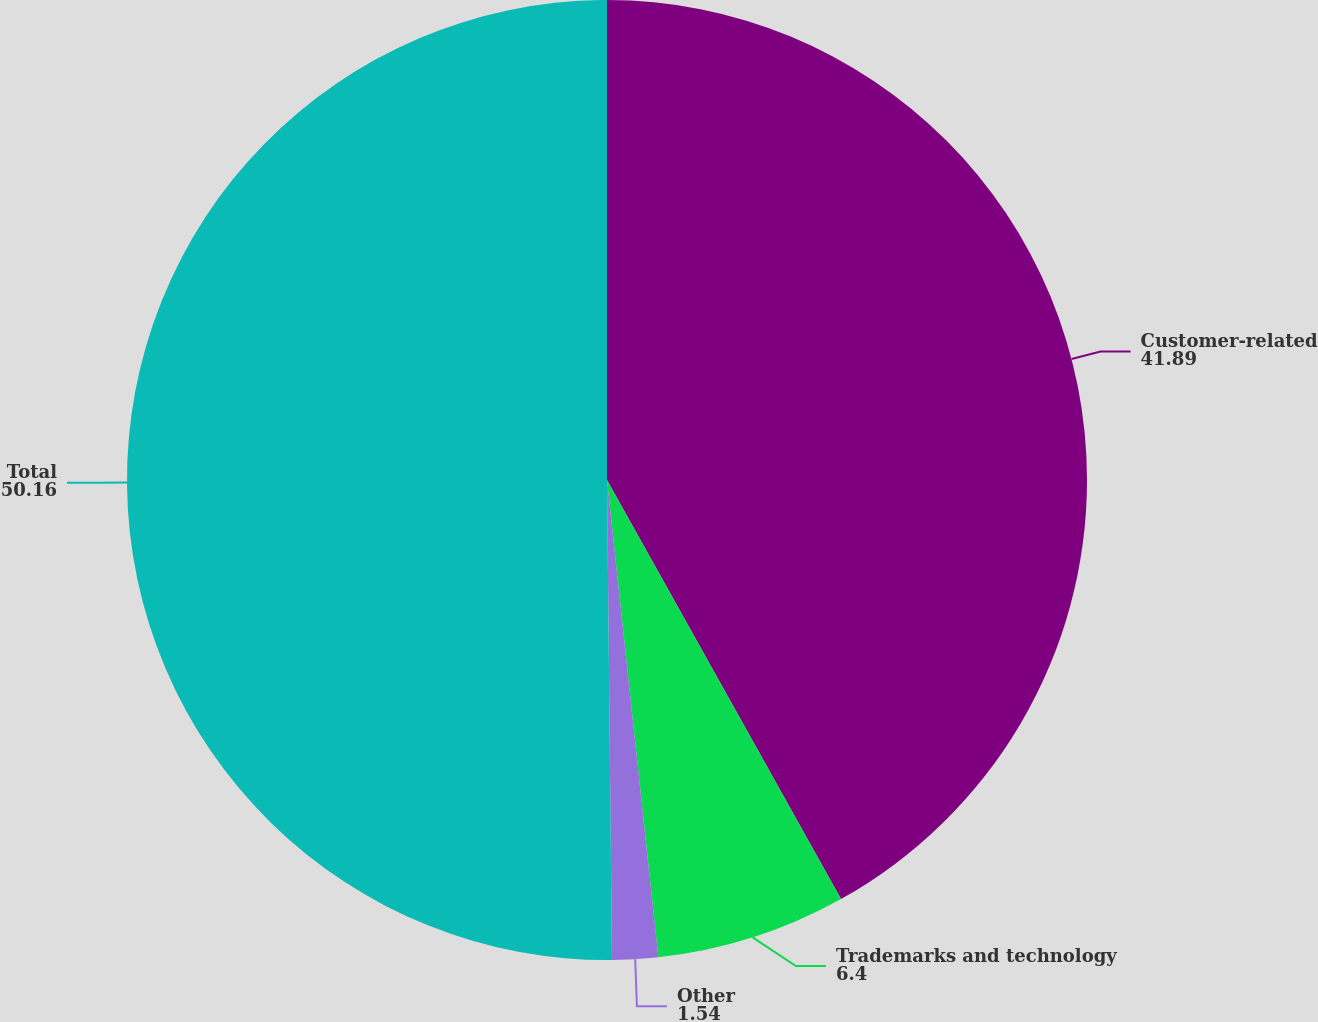Convert chart to OTSL. <chart><loc_0><loc_0><loc_500><loc_500><pie_chart><fcel>Customer-related<fcel>Trademarks and technology<fcel>Other<fcel>Total<nl><fcel>41.89%<fcel>6.4%<fcel>1.54%<fcel>50.16%<nl></chart> 